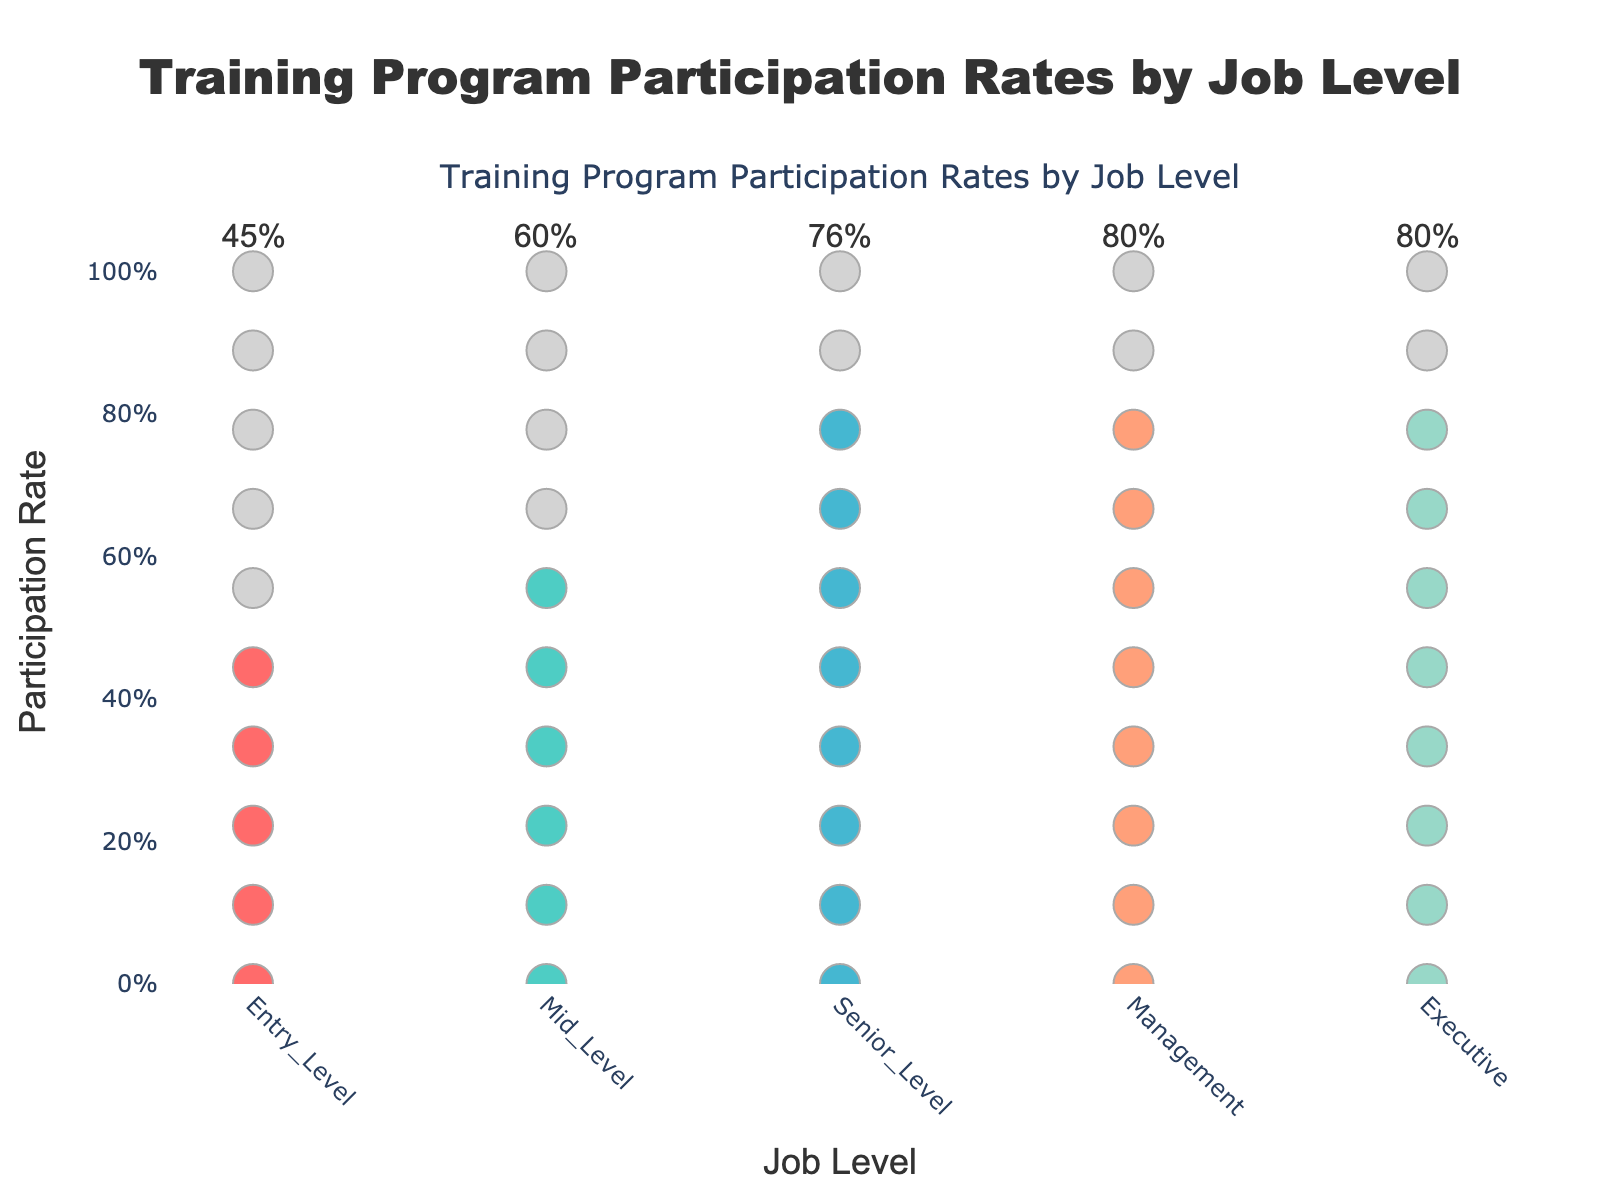What's the title of the figure? The title of the figure is prominently displayed at the top.
Answer: Training Program Participation Rates by Job Level Which job level has the highest participation rate? From the colors and circles filled, identify the job level with the most colored markers.
Answer: Senior Level What's the participation rate for Mid Level employees? Look at the annotation above the Mid Level data points, where the percentage is displayed.
Answer: 60% Compare the participation rates between Entry Level and Executive employees. Which is higher? Count the colored versus grey markers for both Entry Level and Executive levels, or check their annotations.
Answer: Entry Level How do the Mid Level and Management participation rates compare? Compare the visual proportion of colored circles for both Mid Level and Management.
Answer: Mid Level is higher What's the combined participation rate for Entry Level and Senior Level employees? Add the participation rates from Entry Level and Senior Level annotations.
Answer: 83% (45% + 38%) Describe the overall trend in participation rates as job levels increase. Observe how the proportion of colored markers changes from Entry Level to Executive.
Answer: Generally decreases Why is the participation rate for Senior Level highest compared to others? Senior Level has more colored markers proportionally than any other job level.
Answer: Highest among all What is the exact participation rate for Management level employees? Check the annotation above Management which states the percentage.
Answer: 80% If you average the participation rates of all job levels, what would it be? Sum the participation rates (0.45 + 0.60 + 0.76 + 0.80 + 0.80), then divide by 5.
Answer: 68% 